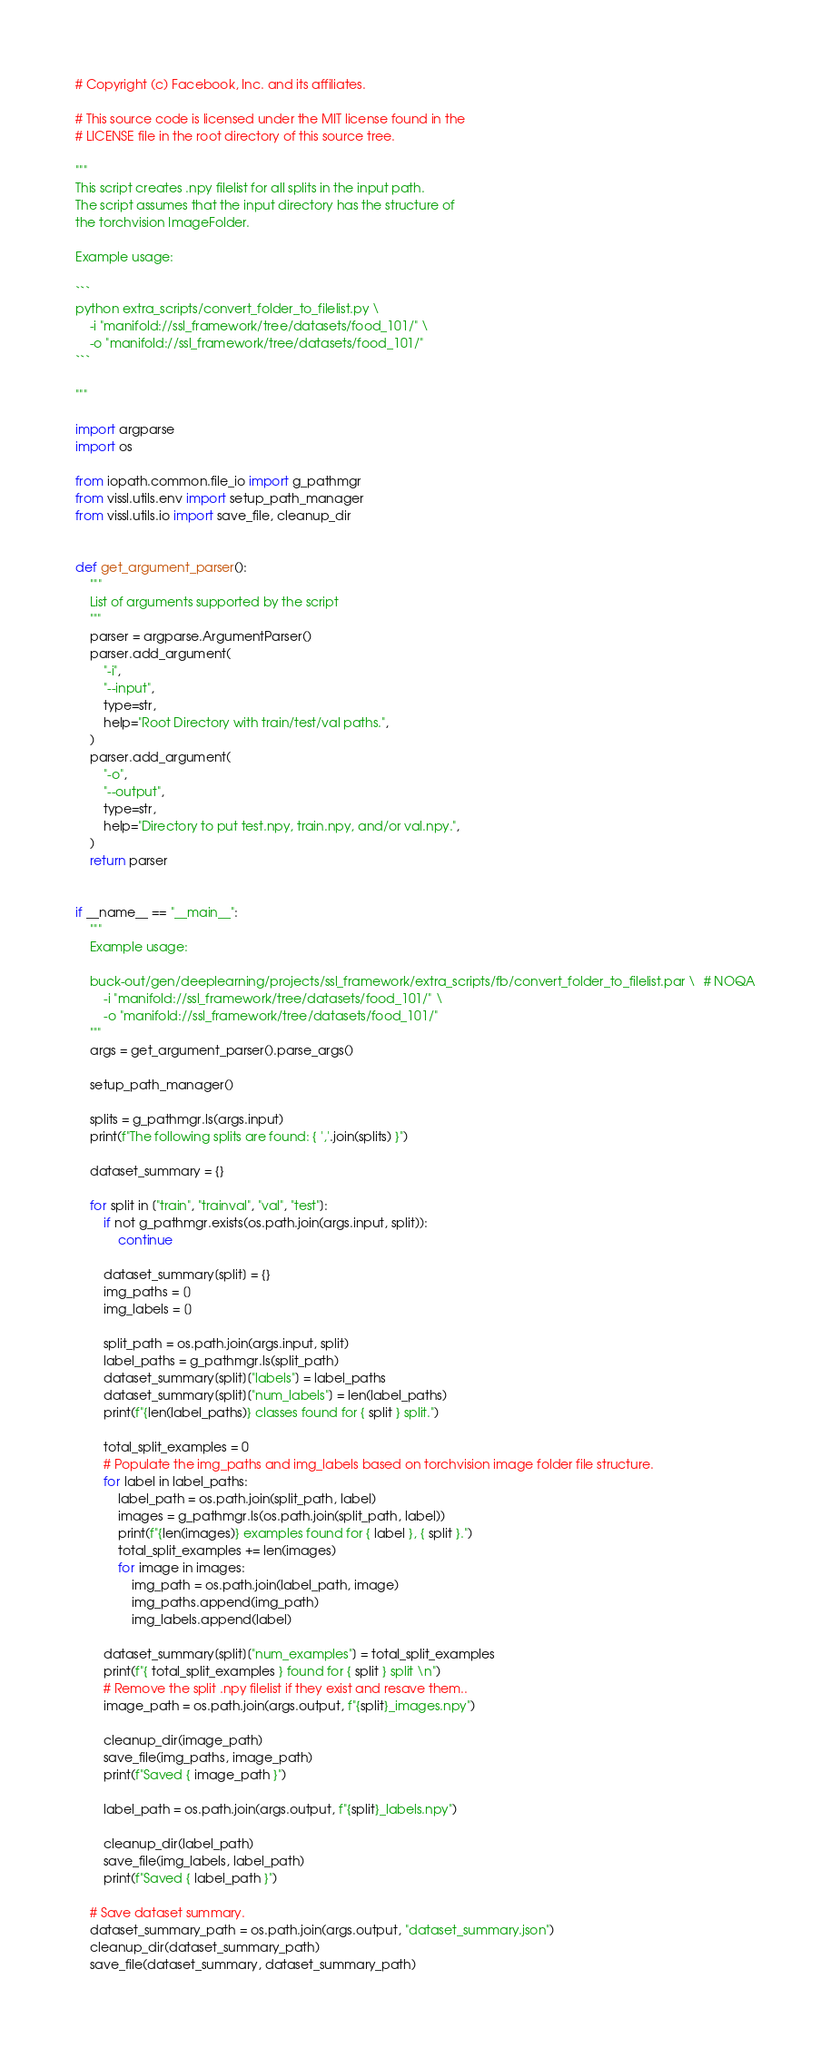Convert code to text. <code><loc_0><loc_0><loc_500><loc_500><_Python_># Copyright (c) Facebook, Inc. and its affiliates.

# This source code is licensed under the MIT license found in the
# LICENSE file in the root directory of this source tree.

"""
This script creates .npy filelist for all splits in the input path.
The script assumes that the input directory has the structure of
the torchvision ImageFolder.

Example usage:

```
python extra_scripts/convert_folder_to_filelist.py \
    -i "manifold://ssl_framework/tree/datasets/food_101/" \
    -o "manifold://ssl_framework/tree/datasets/food_101/"
```

"""

import argparse
import os

from iopath.common.file_io import g_pathmgr
from vissl.utils.env import setup_path_manager
from vissl.utils.io import save_file, cleanup_dir


def get_argument_parser():
    """
    List of arguments supported by the script
    """
    parser = argparse.ArgumentParser()
    parser.add_argument(
        "-i",
        "--input",
        type=str,
        help="Root Directory with train/test/val paths.",
    )
    parser.add_argument(
        "-o",
        "--output",
        type=str,
        help="Directory to put test.npy, train.npy, and/or val.npy.",
    )
    return parser


if __name__ == "__main__":
    """
    Example usage:

    buck-out/gen/deeplearning/projects/ssl_framework/extra_scripts/fb/convert_folder_to_filelist.par \  # NOQA
        -i "manifold://ssl_framework/tree/datasets/food_101/" \
        -o "manifold://ssl_framework/tree/datasets/food_101/"
    """
    args = get_argument_parser().parse_args()

    setup_path_manager()

    splits = g_pathmgr.ls(args.input)
    print(f"The following splits are found: { ','.join(splits) }")

    dataset_summary = {}

    for split in ["train", "trainval", "val", "test"]:
        if not g_pathmgr.exists(os.path.join(args.input, split)):
            continue

        dataset_summary[split] = {}
        img_paths = []
        img_labels = []

        split_path = os.path.join(args.input, split)
        label_paths = g_pathmgr.ls(split_path)
        dataset_summary[split]["labels"] = label_paths
        dataset_summary[split]["num_labels"] = len(label_paths)
        print(f"{len(label_paths)} classes found for { split } split.")

        total_split_examples = 0
        # Populate the img_paths and img_labels based on torchvision image folder file structure.
        for label in label_paths:
            label_path = os.path.join(split_path, label)
            images = g_pathmgr.ls(os.path.join(split_path, label))
            print(f"{len(images)} examples found for { label }, { split }.")
            total_split_examples += len(images)
            for image in images:
                img_path = os.path.join(label_path, image)
                img_paths.append(img_path)
                img_labels.append(label)

        dataset_summary[split]["num_examples"] = total_split_examples
        print(f"{ total_split_examples } found for { split } split \n")
        # Remove the split .npy filelist if they exist and resave them..
        image_path = os.path.join(args.output, f"{split}_images.npy")

        cleanup_dir(image_path)
        save_file(img_paths, image_path)
        print(f"Saved { image_path }")

        label_path = os.path.join(args.output, f"{split}_labels.npy")

        cleanup_dir(label_path)
        save_file(img_labels, label_path)
        print(f"Saved { label_path }")

    # Save dataset summary.
    dataset_summary_path = os.path.join(args.output, "dataset_summary.json")
    cleanup_dir(dataset_summary_path)
    save_file(dataset_summary, dataset_summary_path)
</code> 